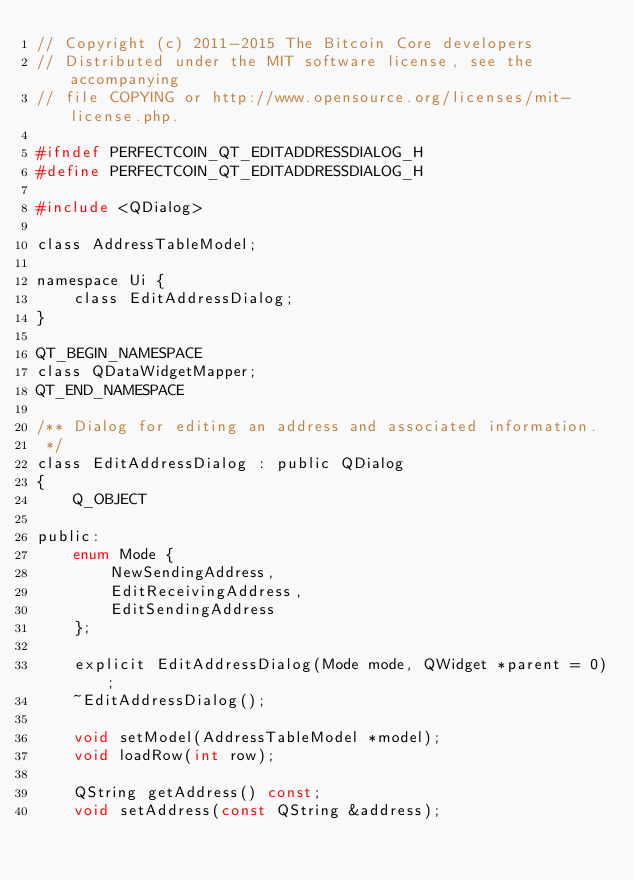<code> <loc_0><loc_0><loc_500><loc_500><_C_>// Copyright (c) 2011-2015 The Bitcoin Core developers
// Distributed under the MIT software license, see the accompanying
// file COPYING or http://www.opensource.org/licenses/mit-license.php.

#ifndef PERFECTCOIN_QT_EDITADDRESSDIALOG_H
#define PERFECTCOIN_QT_EDITADDRESSDIALOG_H

#include <QDialog>

class AddressTableModel;

namespace Ui {
    class EditAddressDialog;
}

QT_BEGIN_NAMESPACE
class QDataWidgetMapper;
QT_END_NAMESPACE

/** Dialog for editing an address and associated information.
 */
class EditAddressDialog : public QDialog
{
    Q_OBJECT

public:
    enum Mode {
        NewSendingAddress,
        EditReceivingAddress,
        EditSendingAddress
    };

    explicit EditAddressDialog(Mode mode, QWidget *parent = 0);
    ~EditAddressDialog();

    void setModel(AddressTableModel *model);
    void loadRow(int row);

    QString getAddress() const;
    void setAddress(const QString &address);
</code> 